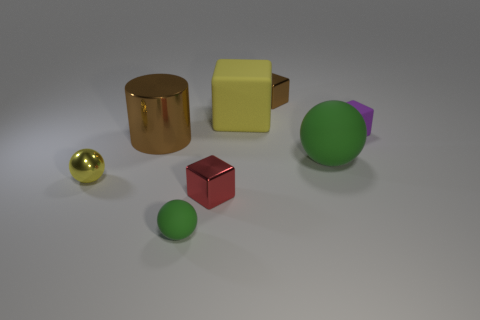There is a tiny shiny cube in front of the small purple block that is in front of the yellow matte thing; what number of large brown things are in front of it?
Your answer should be compact. 0. What material is the big brown object in front of the small block to the right of the small brown shiny thing?
Your response must be concise. Metal. Are there any tiny matte objects that have the same shape as the red metallic object?
Give a very brief answer. Yes. What color is the other rubber object that is the same size as the purple rubber object?
Give a very brief answer. Green. How many things are either tiny things right of the big brown cylinder or small yellow things that are to the left of the big green matte sphere?
Your response must be concise. 5. How many objects are either small red cubes or tiny gray objects?
Make the answer very short. 1. How big is the rubber thing that is to the right of the large yellow cube and in front of the tiny purple block?
Keep it short and to the point. Large. How many other tiny objects are the same material as the small red thing?
Ensure brevity in your answer.  2. The small ball that is made of the same material as the large yellow cube is what color?
Offer a terse response. Green. There is a tiny ball that is in front of the small metallic ball; is its color the same as the large matte sphere?
Provide a succinct answer. Yes. 